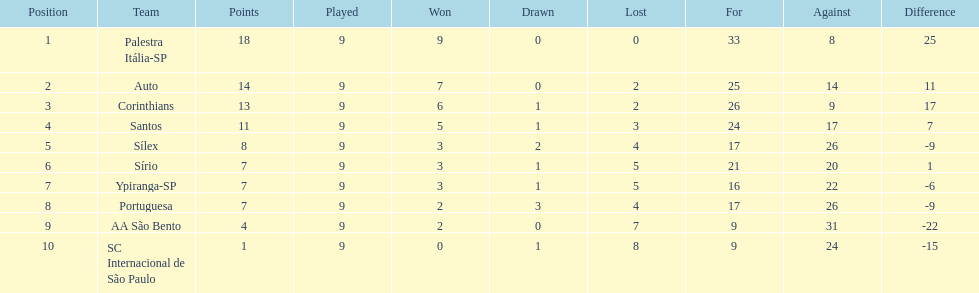How many points did the brazilian football team auto get in 1926? 14. 